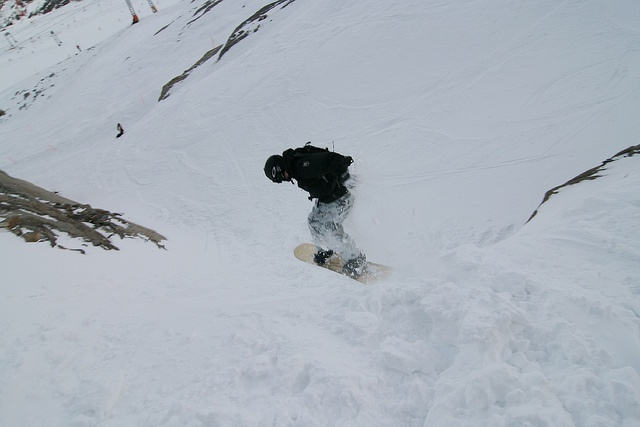Describe the objects in this image and their specific colors. I can see people in gray, black, and darkgray tones, snowboard in gray, darkgray, and lightgray tones, backpack in gray, black, darkgray, and lightgray tones, and people in gray, darkgray, and black tones in this image. 